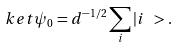<formula> <loc_0><loc_0><loc_500><loc_500>\ k e t { \psi _ { 0 } } = d ^ { - 1 / 2 } \sum _ { i } | i \ > .</formula> 